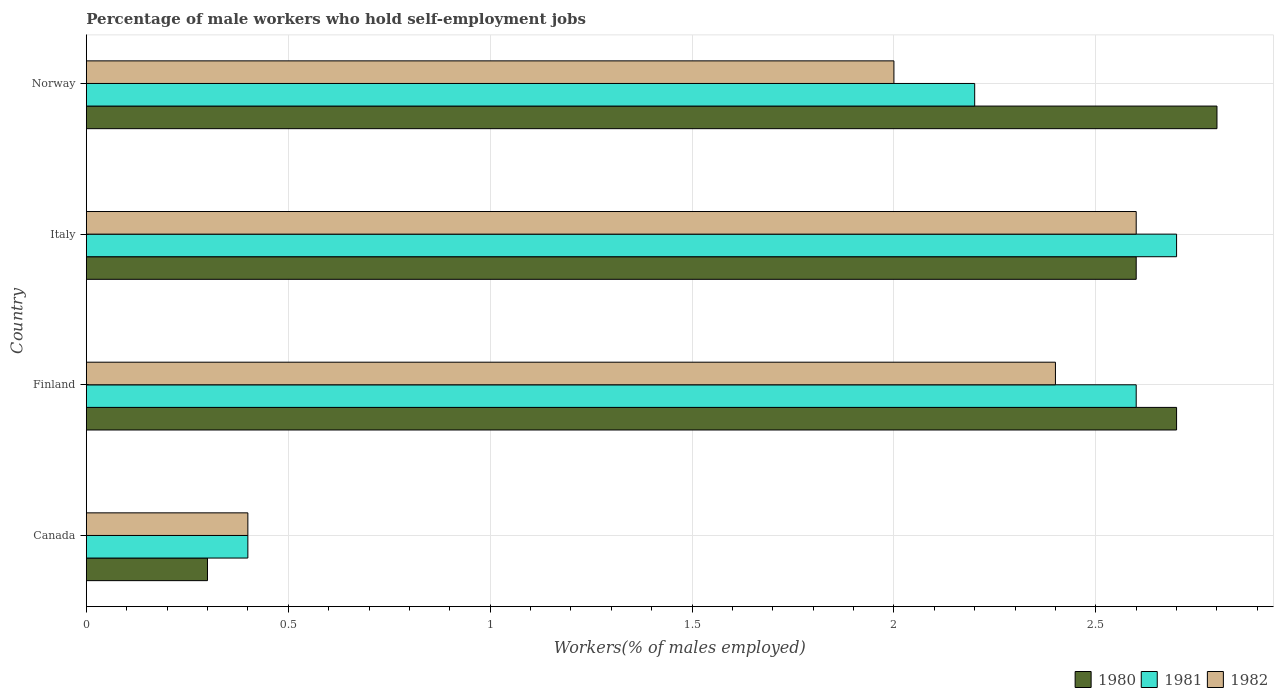How many groups of bars are there?
Ensure brevity in your answer.  4. Are the number of bars per tick equal to the number of legend labels?
Give a very brief answer. Yes. Are the number of bars on each tick of the Y-axis equal?
Your answer should be very brief. Yes. How many bars are there on the 2nd tick from the top?
Ensure brevity in your answer.  3. In how many cases, is the number of bars for a given country not equal to the number of legend labels?
Offer a terse response. 0. What is the percentage of self-employed male workers in 1982 in Canada?
Make the answer very short. 0.4. Across all countries, what is the maximum percentage of self-employed male workers in 1980?
Offer a very short reply. 2.8. Across all countries, what is the minimum percentage of self-employed male workers in 1982?
Make the answer very short. 0.4. In which country was the percentage of self-employed male workers in 1981 maximum?
Give a very brief answer. Italy. In which country was the percentage of self-employed male workers in 1982 minimum?
Your answer should be compact. Canada. What is the total percentage of self-employed male workers in 1982 in the graph?
Provide a succinct answer. 7.4. What is the difference between the percentage of self-employed male workers in 1981 in Finland and that in Norway?
Your response must be concise. 0.4. What is the difference between the percentage of self-employed male workers in 1982 in Italy and the percentage of self-employed male workers in 1981 in Canada?
Offer a very short reply. 2.2. What is the average percentage of self-employed male workers in 1982 per country?
Ensure brevity in your answer.  1.85. What is the difference between the percentage of self-employed male workers in 1981 and percentage of self-employed male workers in 1982 in Italy?
Provide a short and direct response. 0.1. In how many countries, is the percentage of self-employed male workers in 1981 greater than 1.7 %?
Keep it short and to the point. 3. What is the ratio of the percentage of self-employed male workers in 1980 in Finland to that in Italy?
Offer a terse response. 1.04. Is the percentage of self-employed male workers in 1980 in Canada less than that in Finland?
Your answer should be compact. Yes. Is the difference between the percentage of self-employed male workers in 1981 in Finland and Norway greater than the difference between the percentage of self-employed male workers in 1982 in Finland and Norway?
Provide a succinct answer. No. What is the difference between the highest and the second highest percentage of self-employed male workers in 1980?
Offer a terse response. 0.1. What is the difference between the highest and the lowest percentage of self-employed male workers in 1980?
Your answer should be very brief. 2.5. Is the sum of the percentage of self-employed male workers in 1981 in Italy and Norway greater than the maximum percentage of self-employed male workers in 1980 across all countries?
Give a very brief answer. Yes. Is it the case that in every country, the sum of the percentage of self-employed male workers in 1982 and percentage of self-employed male workers in 1981 is greater than the percentage of self-employed male workers in 1980?
Keep it short and to the point. Yes. Are all the bars in the graph horizontal?
Your response must be concise. Yes. How many legend labels are there?
Make the answer very short. 3. What is the title of the graph?
Offer a very short reply. Percentage of male workers who hold self-employment jobs. Does "2012" appear as one of the legend labels in the graph?
Give a very brief answer. No. What is the label or title of the X-axis?
Provide a short and direct response. Workers(% of males employed). What is the label or title of the Y-axis?
Your response must be concise. Country. What is the Workers(% of males employed) in 1980 in Canada?
Ensure brevity in your answer.  0.3. What is the Workers(% of males employed) in 1981 in Canada?
Your answer should be very brief. 0.4. What is the Workers(% of males employed) of 1982 in Canada?
Make the answer very short. 0.4. What is the Workers(% of males employed) in 1980 in Finland?
Make the answer very short. 2.7. What is the Workers(% of males employed) in 1981 in Finland?
Your answer should be very brief. 2.6. What is the Workers(% of males employed) of 1982 in Finland?
Your answer should be very brief. 2.4. What is the Workers(% of males employed) of 1980 in Italy?
Give a very brief answer. 2.6. What is the Workers(% of males employed) in 1981 in Italy?
Keep it short and to the point. 2.7. What is the Workers(% of males employed) in 1982 in Italy?
Offer a terse response. 2.6. What is the Workers(% of males employed) of 1980 in Norway?
Provide a succinct answer. 2.8. What is the Workers(% of males employed) of 1981 in Norway?
Offer a terse response. 2.2. Across all countries, what is the maximum Workers(% of males employed) in 1980?
Your answer should be very brief. 2.8. Across all countries, what is the maximum Workers(% of males employed) of 1981?
Give a very brief answer. 2.7. Across all countries, what is the maximum Workers(% of males employed) in 1982?
Provide a short and direct response. 2.6. Across all countries, what is the minimum Workers(% of males employed) of 1980?
Provide a short and direct response. 0.3. Across all countries, what is the minimum Workers(% of males employed) in 1981?
Give a very brief answer. 0.4. Across all countries, what is the minimum Workers(% of males employed) of 1982?
Your response must be concise. 0.4. What is the total Workers(% of males employed) in 1982 in the graph?
Your response must be concise. 7.4. What is the difference between the Workers(% of males employed) of 1981 in Canada and that in Finland?
Make the answer very short. -2.2. What is the difference between the Workers(% of males employed) in 1980 in Canada and that in Italy?
Keep it short and to the point. -2.3. What is the difference between the Workers(% of males employed) of 1981 in Canada and that in Italy?
Offer a very short reply. -2.3. What is the difference between the Workers(% of males employed) in 1980 in Canada and that in Norway?
Make the answer very short. -2.5. What is the difference between the Workers(% of males employed) in 1981 in Canada and that in Norway?
Make the answer very short. -1.8. What is the difference between the Workers(% of males employed) in 1982 in Finland and that in Italy?
Offer a very short reply. -0.2. What is the difference between the Workers(% of males employed) of 1981 in Finland and that in Norway?
Make the answer very short. 0.4. What is the difference between the Workers(% of males employed) in 1982 in Finland and that in Norway?
Make the answer very short. 0.4. What is the difference between the Workers(% of males employed) in 1980 in Italy and that in Norway?
Provide a short and direct response. -0.2. What is the difference between the Workers(% of males employed) in 1980 in Canada and the Workers(% of males employed) in 1981 in Finland?
Keep it short and to the point. -2.3. What is the difference between the Workers(% of males employed) of 1980 in Canada and the Workers(% of males employed) of 1982 in Finland?
Provide a short and direct response. -2.1. What is the difference between the Workers(% of males employed) of 1981 in Canada and the Workers(% of males employed) of 1982 in Finland?
Ensure brevity in your answer.  -2. What is the difference between the Workers(% of males employed) in 1980 in Canada and the Workers(% of males employed) in 1981 in Italy?
Keep it short and to the point. -2.4. What is the difference between the Workers(% of males employed) of 1980 in Canada and the Workers(% of males employed) of 1982 in Italy?
Offer a very short reply. -2.3. What is the difference between the Workers(% of males employed) in 1981 in Canada and the Workers(% of males employed) in 1982 in Italy?
Give a very brief answer. -2.2. What is the difference between the Workers(% of males employed) of 1980 in Canada and the Workers(% of males employed) of 1981 in Norway?
Make the answer very short. -1.9. What is the difference between the Workers(% of males employed) of 1980 in Canada and the Workers(% of males employed) of 1982 in Norway?
Provide a short and direct response. -1.7. What is the difference between the Workers(% of males employed) of 1981 in Canada and the Workers(% of males employed) of 1982 in Norway?
Your response must be concise. -1.6. What is the difference between the Workers(% of males employed) of 1980 in Finland and the Workers(% of males employed) of 1981 in Norway?
Your answer should be compact. 0.5. What is the difference between the Workers(% of males employed) in 1980 in Finland and the Workers(% of males employed) in 1982 in Norway?
Provide a succinct answer. 0.7. What is the difference between the Workers(% of males employed) of 1981 in Finland and the Workers(% of males employed) of 1982 in Norway?
Ensure brevity in your answer.  0.6. What is the difference between the Workers(% of males employed) of 1980 in Italy and the Workers(% of males employed) of 1981 in Norway?
Provide a succinct answer. 0.4. What is the difference between the Workers(% of males employed) of 1980 in Italy and the Workers(% of males employed) of 1982 in Norway?
Provide a succinct answer. 0.6. What is the average Workers(% of males employed) of 1980 per country?
Give a very brief answer. 2.1. What is the average Workers(% of males employed) in 1981 per country?
Your answer should be very brief. 1.98. What is the average Workers(% of males employed) in 1982 per country?
Give a very brief answer. 1.85. What is the difference between the Workers(% of males employed) of 1980 and Workers(% of males employed) of 1982 in Canada?
Provide a succinct answer. -0.1. What is the difference between the Workers(% of males employed) in 1981 and Workers(% of males employed) in 1982 in Canada?
Your answer should be compact. 0. What is the difference between the Workers(% of males employed) in 1980 and Workers(% of males employed) in 1982 in Finland?
Offer a terse response. 0.3. What is the difference between the Workers(% of males employed) in 1980 and Workers(% of males employed) in 1982 in Norway?
Provide a succinct answer. 0.8. What is the difference between the Workers(% of males employed) in 1981 and Workers(% of males employed) in 1982 in Norway?
Provide a succinct answer. 0.2. What is the ratio of the Workers(% of males employed) of 1980 in Canada to that in Finland?
Your answer should be very brief. 0.11. What is the ratio of the Workers(% of males employed) of 1981 in Canada to that in Finland?
Offer a terse response. 0.15. What is the ratio of the Workers(% of males employed) in 1982 in Canada to that in Finland?
Keep it short and to the point. 0.17. What is the ratio of the Workers(% of males employed) of 1980 in Canada to that in Italy?
Your answer should be compact. 0.12. What is the ratio of the Workers(% of males employed) of 1981 in Canada to that in Italy?
Provide a short and direct response. 0.15. What is the ratio of the Workers(% of males employed) of 1982 in Canada to that in Italy?
Keep it short and to the point. 0.15. What is the ratio of the Workers(% of males employed) in 1980 in Canada to that in Norway?
Make the answer very short. 0.11. What is the ratio of the Workers(% of males employed) of 1981 in Canada to that in Norway?
Provide a short and direct response. 0.18. What is the ratio of the Workers(% of males employed) of 1982 in Canada to that in Norway?
Offer a terse response. 0.2. What is the ratio of the Workers(% of males employed) of 1981 in Finland to that in Italy?
Your response must be concise. 0.96. What is the ratio of the Workers(% of males employed) in 1982 in Finland to that in Italy?
Give a very brief answer. 0.92. What is the ratio of the Workers(% of males employed) in 1981 in Finland to that in Norway?
Make the answer very short. 1.18. What is the ratio of the Workers(% of males employed) of 1982 in Finland to that in Norway?
Give a very brief answer. 1.2. What is the ratio of the Workers(% of males employed) of 1980 in Italy to that in Norway?
Your answer should be very brief. 0.93. What is the ratio of the Workers(% of males employed) of 1981 in Italy to that in Norway?
Provide a short and direct response. 1.23. What is the difference between the highest and the second highest Workers(% of males employed) in 1980?
Your answer should be very brief. 0.1. What is the difference between the highest and the second highest Workers(% of males employed) of 1982?
Give a very brief answer. 0.2. What is the difference between the highest and the lowest Workers(% of males employed) of 1980?
Give a very brief answer. 2.5. What is the difference between the highest and the lowest Workers(% of males employed) of 1981?
Your response must be concise. 2.3. What is the difference between the highest and the lowest Workers(% of males employed) of 1982?
Offer a very short reply. 2.2. 